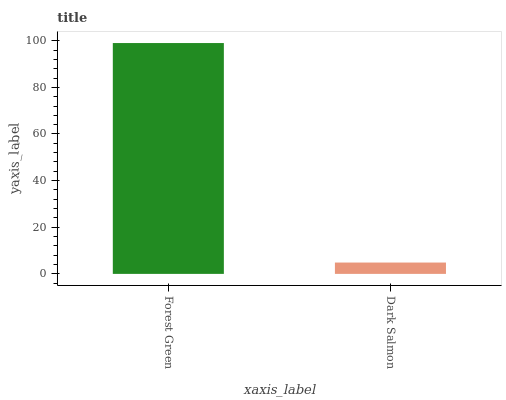Is Dark Salmon the minimum?
Answer yes or no. Yes. Is Forest Green the maximum?
Answer yes or no. Yes. Is Dark Salmon the maximum?
Answer yes or no. No. Is Forest Green greater than Dark Salmon?
Answer yes or no. Yes. Is Dark Salmon less than Forest Green?
Answer yes or no. Yes. Is Dark Salmon greater than Forest Green?
Answer yes or no. No. Is Forest Green less than Dark Salmon?
Answer yes or no. No. Is Forest Green the high median?
Answer yes or no. Yes. Is Dark Salmon the low median?
Answer yes or no. Yes. Is Dark Salmon the high median?
Answer yes or no. No. Is Forest Green the low median?
Answer yes or no. No. 